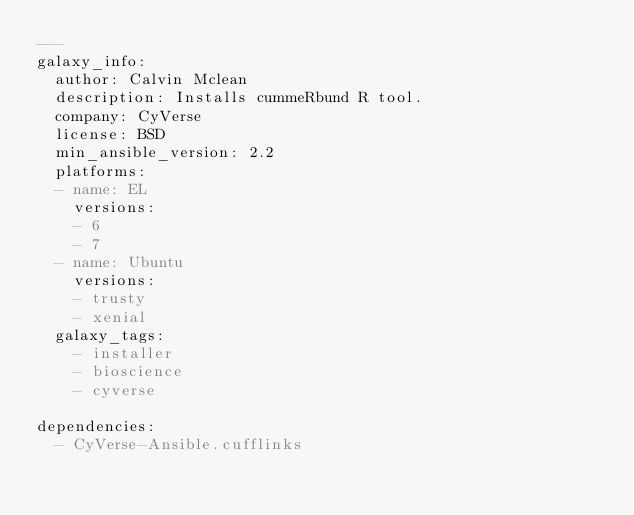Convert code to text. <code><loc_0><loc_0><loc_500><loc_500><_YAML_>---
galaxy_info:
  author: Calvin Mclean
  description: Installs cummeRbund R tool.
  company: CyVerse
  license: BSD
  min_ansible_version: 2.2
  platforms:
  - name: EL
    versions:
    - 6
    - 7
  - name: Ubuntu
    versions:
    - trusty
    - xenial
  galaxy_tags:
    - installer
    - bioscience
    - cyverse

dependencies:
  - CyVerse-Ansible.cufflinks
</code> 